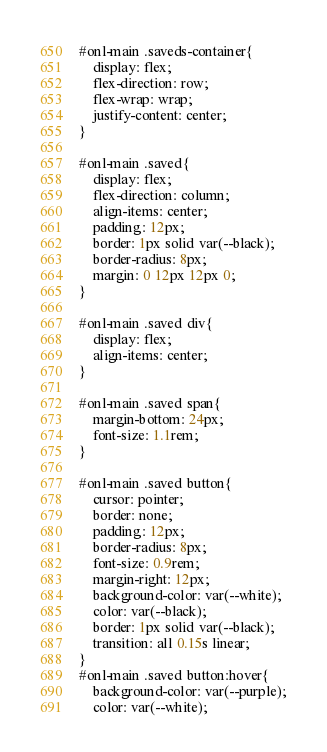<code> <loc_0><loc_0><loc_500><loc_500><_CSS_>#onl-main .saveds-container{
    display: flex;
    flex-direction: row;
    flex-wrap: wrap;
    justify-content: center;
}

#onl-main .saved{
    display: flex;
    flex-direction: column;
    align-items: center;
    padding: 12px;
    border: 1px solid var(--black);
    border-radius: 8px;
    margin: 0 12px 12px 0;
}

#onl-main .saved div{
    display: flex;
    align-items: center;
}

#onl-main .saved span{
    margin-bottom: 24px;
    font-size: 1.1rem;
}

#onl-main .saved button{
    cursor: pointer;
    border: none;
    padding: 12px;
    border-radius: 8px;
    font-size: 0.9rem;
    margin-right: 12px;
    background-color: var(--white);
    color: var(--black);
    border: 1px solid var(--black);
    transition: all 0.15s linear;
}
#onl-main .saved button:hover{
    background-color: var(--purple);
    color: var(--white);</code> 